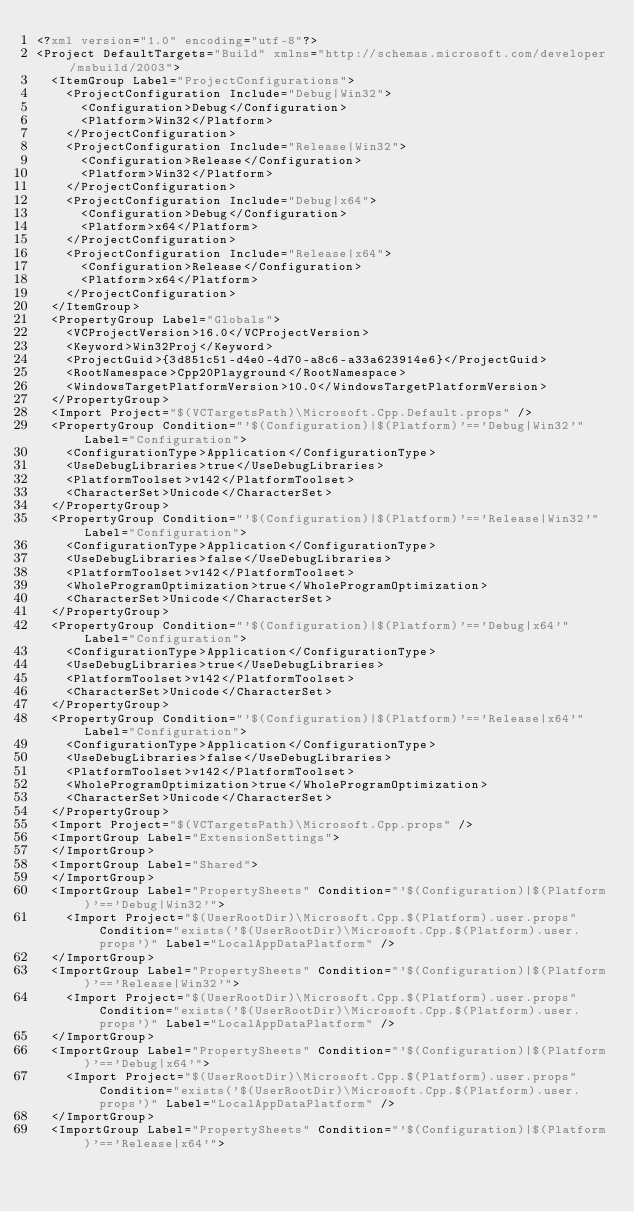Convert code to text. <code><loc_0><loc_0><loc_500><loc_500><_XML_><?xml version="1.0" encoding="utf-8"?>
<Project DefaultTargets="Build" xmlns="http://schemas.microsoft.com/developer/msbuild/2003">
  <ItemGroup Label="ProjectConfigurations">
    <ProjectConfiguration Include="Debug|Win32">
      <Configuration>Debug</Configuration>
      <Platform>Win32</Platform>
    </ProjectConfiguration>
    <ProjectConfiguration Include="Release|Win32">
      <Configuration>Release</Configuration>
      <Platform>Win32</Platform>
    </ProjectConfiguration>
    <ProjectConfiguration Include="Debug|x64">
      <Configuration>Debug</Configuration>
      <Platform>x64</Platform>
    </ProjectConfiguration>
    <ProjectConfiguration Include="Release|x64">
      <Configuration>Release</Configuration>
      <Platform>x64</Platform>
    </ProjectConfiguration>
  </ItemGroup>
  <PropertyGroup Label="Globals">
    <VCProjectVersion>16.0</VCProjectVersion>
    <Keyword>Win32Proj</Keyword>
    <ProjectGuid>{3d851c51-d4e0-4d70-a8c6-a33a623914e6}</ProjectGuid>
    <RootNamespace>Cpp20Playground</RootNamespace>
    <WindowsTargetPlatformVersion>10.0</WindowsTargetPlatformVersion>
  </PropertyGroup>
  <Import Project="$(VCTargetsPath)\Microsoft.Cpp.Default.props" />
  <PropertyGroup Condition="'$(Configuration)|$(Platform)'=='Debug|Win32'" Label="Configuration">
    <ConfigurationType>Application</ConfigurationType>
    <UseDebugLibraries>true</UseDebugLibraries>
    <PlatformToolset>v142</PlatformToolset>
    <CharacterSet>Unicode</CharacterSet>
  </PropertyGroup>
  <PropertyGroup Condition="'$(Configuration)|$(Platform)'=='Release|Win32'" Label="Configuration">
    <ConfigurationType>Application</ConfigurationType>
    <UseDebugLibraries>false</UseDebugLibraries>
    <PlatformToolset>v142</PlatformToolset>
    <WholeProgramOptimization>true</WholeProgramOptimization>
    <CharacterSet>Unicode</CharacterSet>
  </PropertyGroup>
  <PropertyGroup Condition="'$(Configuration)|$(Platform)'=='Debug|x64'" Label="Configuration">
    <ConfigurationType>Application</ConfigurationType>
    <UseDebugLibraries>true</UseDebugLibraries>
    <PlatformToolset>v142</PlatformToolset>
    <CharacterSet>Unicode</CharacterSet>
  </PropertyGroup>
  <PropertyGroup Condition="'$(Configuration)|$(Platform)'=='Release|x64'" Label="Configuration">
    <ConfigurationType>Application</ConfigurationType>
    <UseDebugLibraries>false</UseDebugLibraries>
    <PlatformToolset>v142</PlatformToolset>
    <WholeProgramOptimization>true</WholeProgramOptimization>
    <CharacterSet>Unicode</CharacterSet>
  </PropertyGroup>
  <Import Project="$(VCTargetsPath)\Microsoft.Cpp.props" />
  <ImportGroup Label="ExtensionSettings">
  </ImportGroup>
  <ImportGroup Label="Shared">
  </ImportGroup>
  <ImportGroup Label="PropertySheets" Condition="'$(Configuration)|$(Platform)'=='Debug|Win32'">
    <Import Project="$(UserRootDir)\Microsoft.Cpp.$(Platform).user.props" Condition="exists('$(UserRootDir)\Microsoft.Cpp.$(Platform).user.props')" Label="LocalAppDataPlatform" />
  </ImportGroup>
  <ImportGroup Label="PropertySheets" Condition="'$(Configuration)|$(Platform)'=='Release|Win32'">
    <Import Project="$(UserRootDir)\Microsoft.Cpp.$(Platform).user.props" Condition="exists('$(UserRootDir)\Microsoft.Cpp.$(Platform).user.props')" Label="LocalAppDataPlatform" />
  </ImportGroup>
  <ImportGroup Label="PropertySheets" Condition="'$(Configuration)|$(Platform)'=='Debug|x64'">
    <Import Project="$(UserRootDir)\Microsoft.Cpp.$(Platform).user.props" Condition="exists('$(UserRootDir)\Microsoft.Cpp.$(Platform).user.props')" Label="LocalAppDataPlatform" />
  </ImportGroup>
  <ImportGroup Label="PropertySheets" Condition="'$(Configuration)|$(Platform)'=='Release|x64'"></code> 